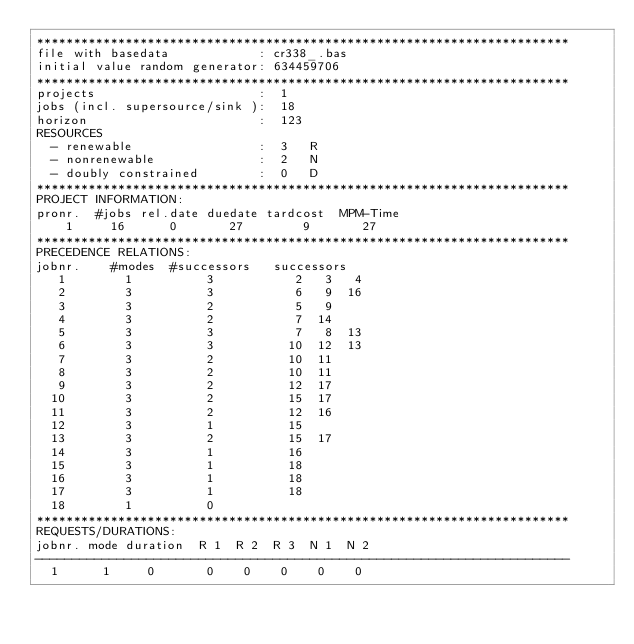<code> <loc_0><loc_0><loc_500><loc_500><_ObjectiveC_>************************************************************************
file with basedata            : cr338_.bas
initial value random generator: 634459706
************************************************************************
projects                      :  1
jobs (incl. supersource/sink ):  18
horizon                       :  123
RESOURCES
  - renewable                 :  3   R
  - nonrenewable              :  2   N
  - doubly constrained        :  0   D
************************************************************************
PROJECT INFORMATION:
pronr.  #jobs rel.date duedate tardcost  MPM-Time
    1     16      0       27        9       27
************************************************************************
PRECEDENCE RELATIONS:
jobnr.    #modes  #successors   successors
   1        1          3           2   3   4
   2        3          3           6   9  16
   3        3          2           5   9
   4        3          2           7  14
   5        3          3           7   8  13
   6        3          3          10  12  13
   7        3          2          10  11
   8        3          2          10  11
   9        3          2          12  17
  10        3          2          15  17
  11        3          2          12  16
  12        3          1          15
  13        3          2          15  17
  14        3          1          16
  15        3          1          18
  16        3          1          18
  17        3          1          18
  18        1          0        
************************************************************************
REQUESTS/DURATIONS:
jobnr. mode duration  R 1  R 2  R 3  N 1  N 2
------------------------------------------------------------------------
  1      1     0       0    0    0    0    0</code> 